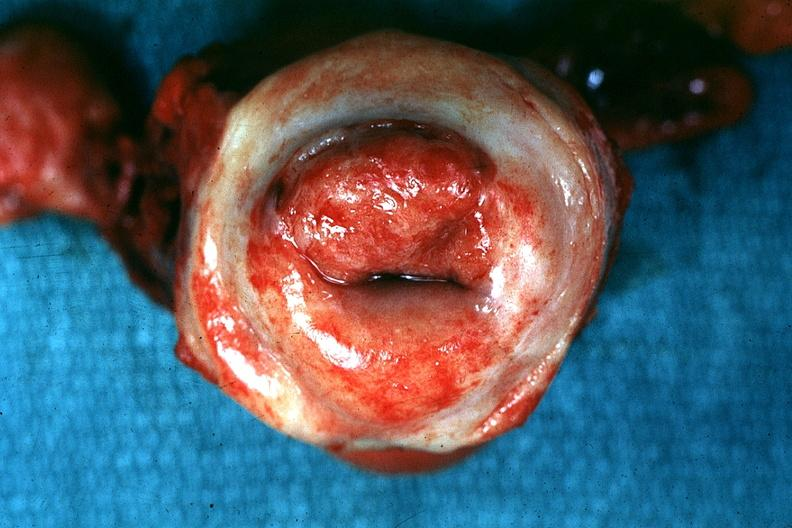what does this image show?
Answer the question using a single word or phrase. Excellent example tumor labeled as invasive 